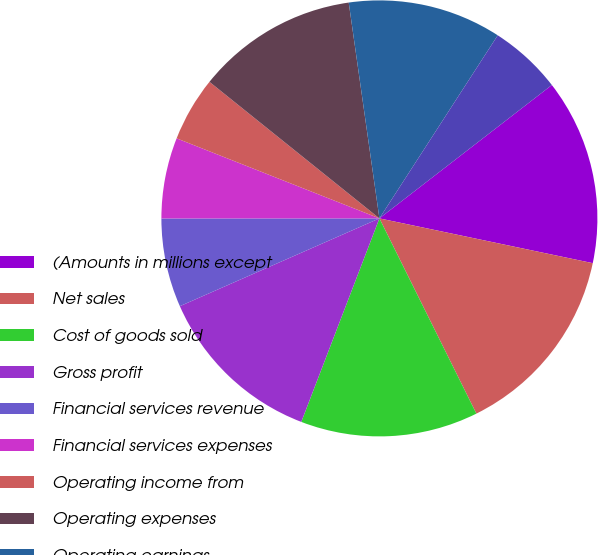Convert chart to OTSL. <chart><loc_0><loc_0><loc_500><loc_500><pie_chart><fcel>(Amounts in millions except<fcel>Net sales<fcel>Cost of goods sold<fcel>Gross profit<fcel>Financial services revenue<fcel>Financial services expenses<fcel>Operating income from<fcel>Operating expenses<fcel>Operating earnings<fcel>Interest expense<nl><fcel>13.77%<fcel>14.37%<fcel>13.17%<fcel>12.57%<fcel>6.59%<fcel>5.99%<fcel>4.79%<fcel>11.98%<fcel>11.38%<fcel>5.39%<nl></chart> 